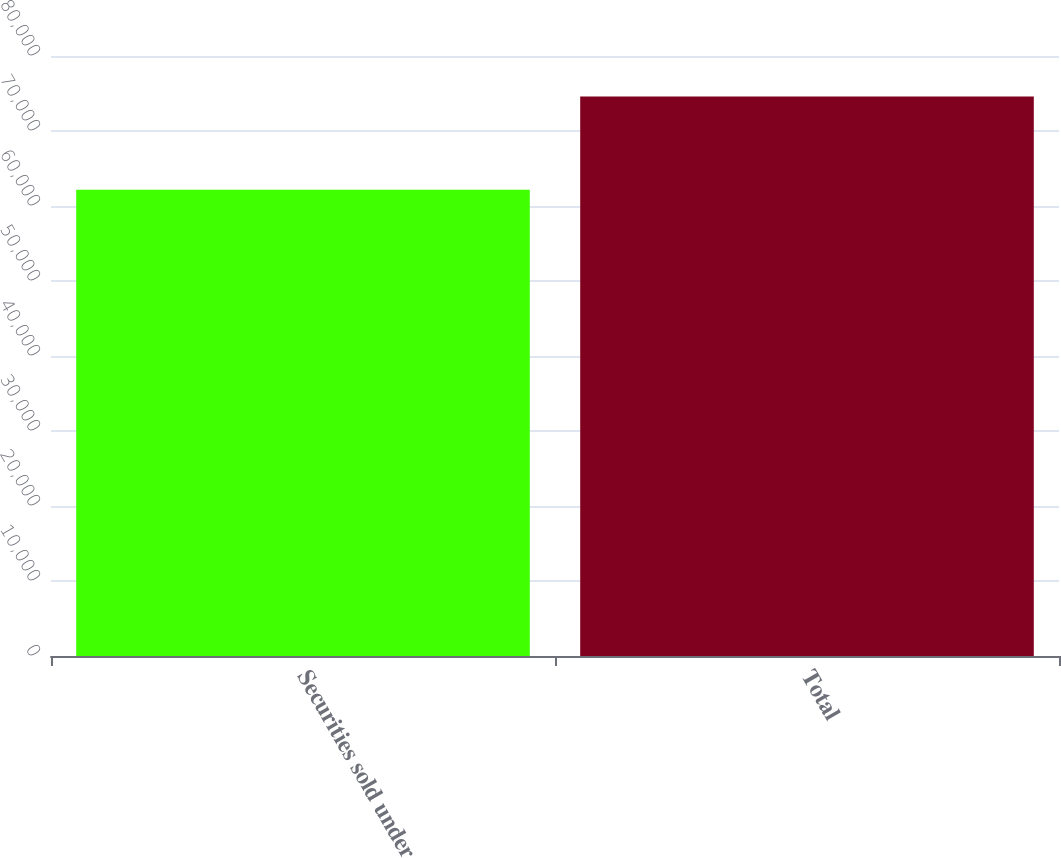Convert chart. <chart><loc_0><loc_0><loc_500><loc_500><bar_chart><fcel>Securities sold under<fcel>Total<nl><fcel>62168<fcel>74597<nl></chart> 